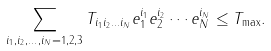<formula> <loc_0><loc_0><loc_500><loc_500>\sum _ { i _ { 1 } , i _ { 2 } , \dots , i _ { N } = 1 , 2 , 3 } T _ { i _ { 1 } i _ { 2 } \dots i _ { N } } e ^ { i _ { 1 } } _ { 1 } e ^ { i _ { 2 } } _ { 2 } \cdots e ^ { i _ { N } } _ { N } \leq T _ { \max } .</formula> 